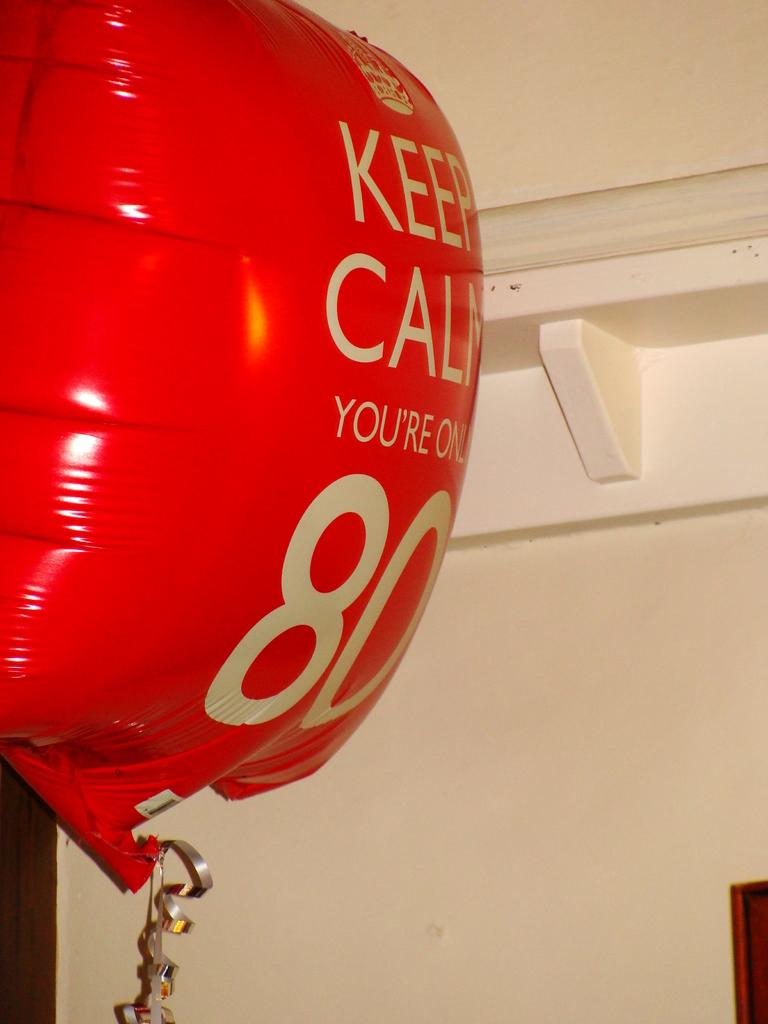<image>
Share a concise interpretation of the image provided. A red helium balloon that says keep calm, your'e only 80. 